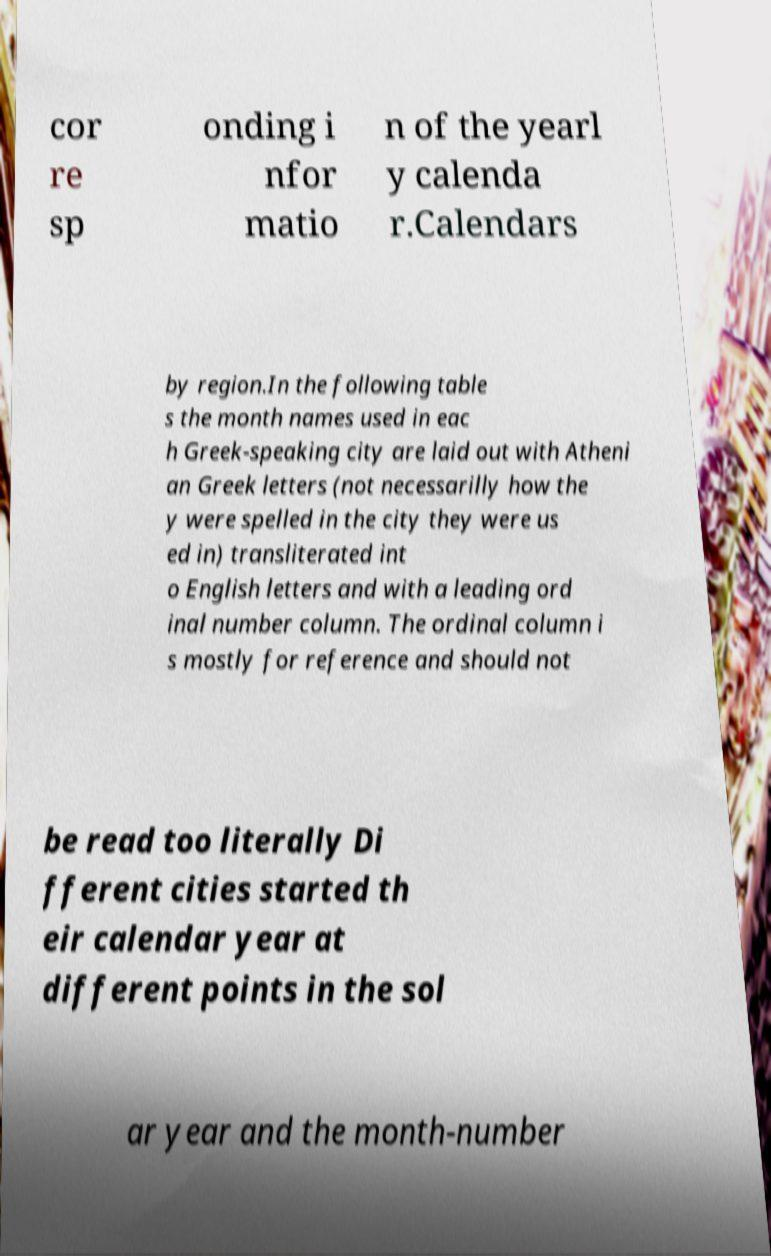I need the written content from this picture converted into text. Can you do that? cor re sp onding i nfor matio n of the yearl y calenda r.Calendars by region.In the following table s the month names used in eac h Greek-speaking city are laid out with Atheni an Greek letters (not necessarilly how the y were spelled in the city they were us ed in) transliterated int o English letters and with a leading ord inal number column. The ordinal column i s mostly for reference and should not be read too literally Di fferent cities started th eir calendar year at different points in the sol ar year and the month-number 